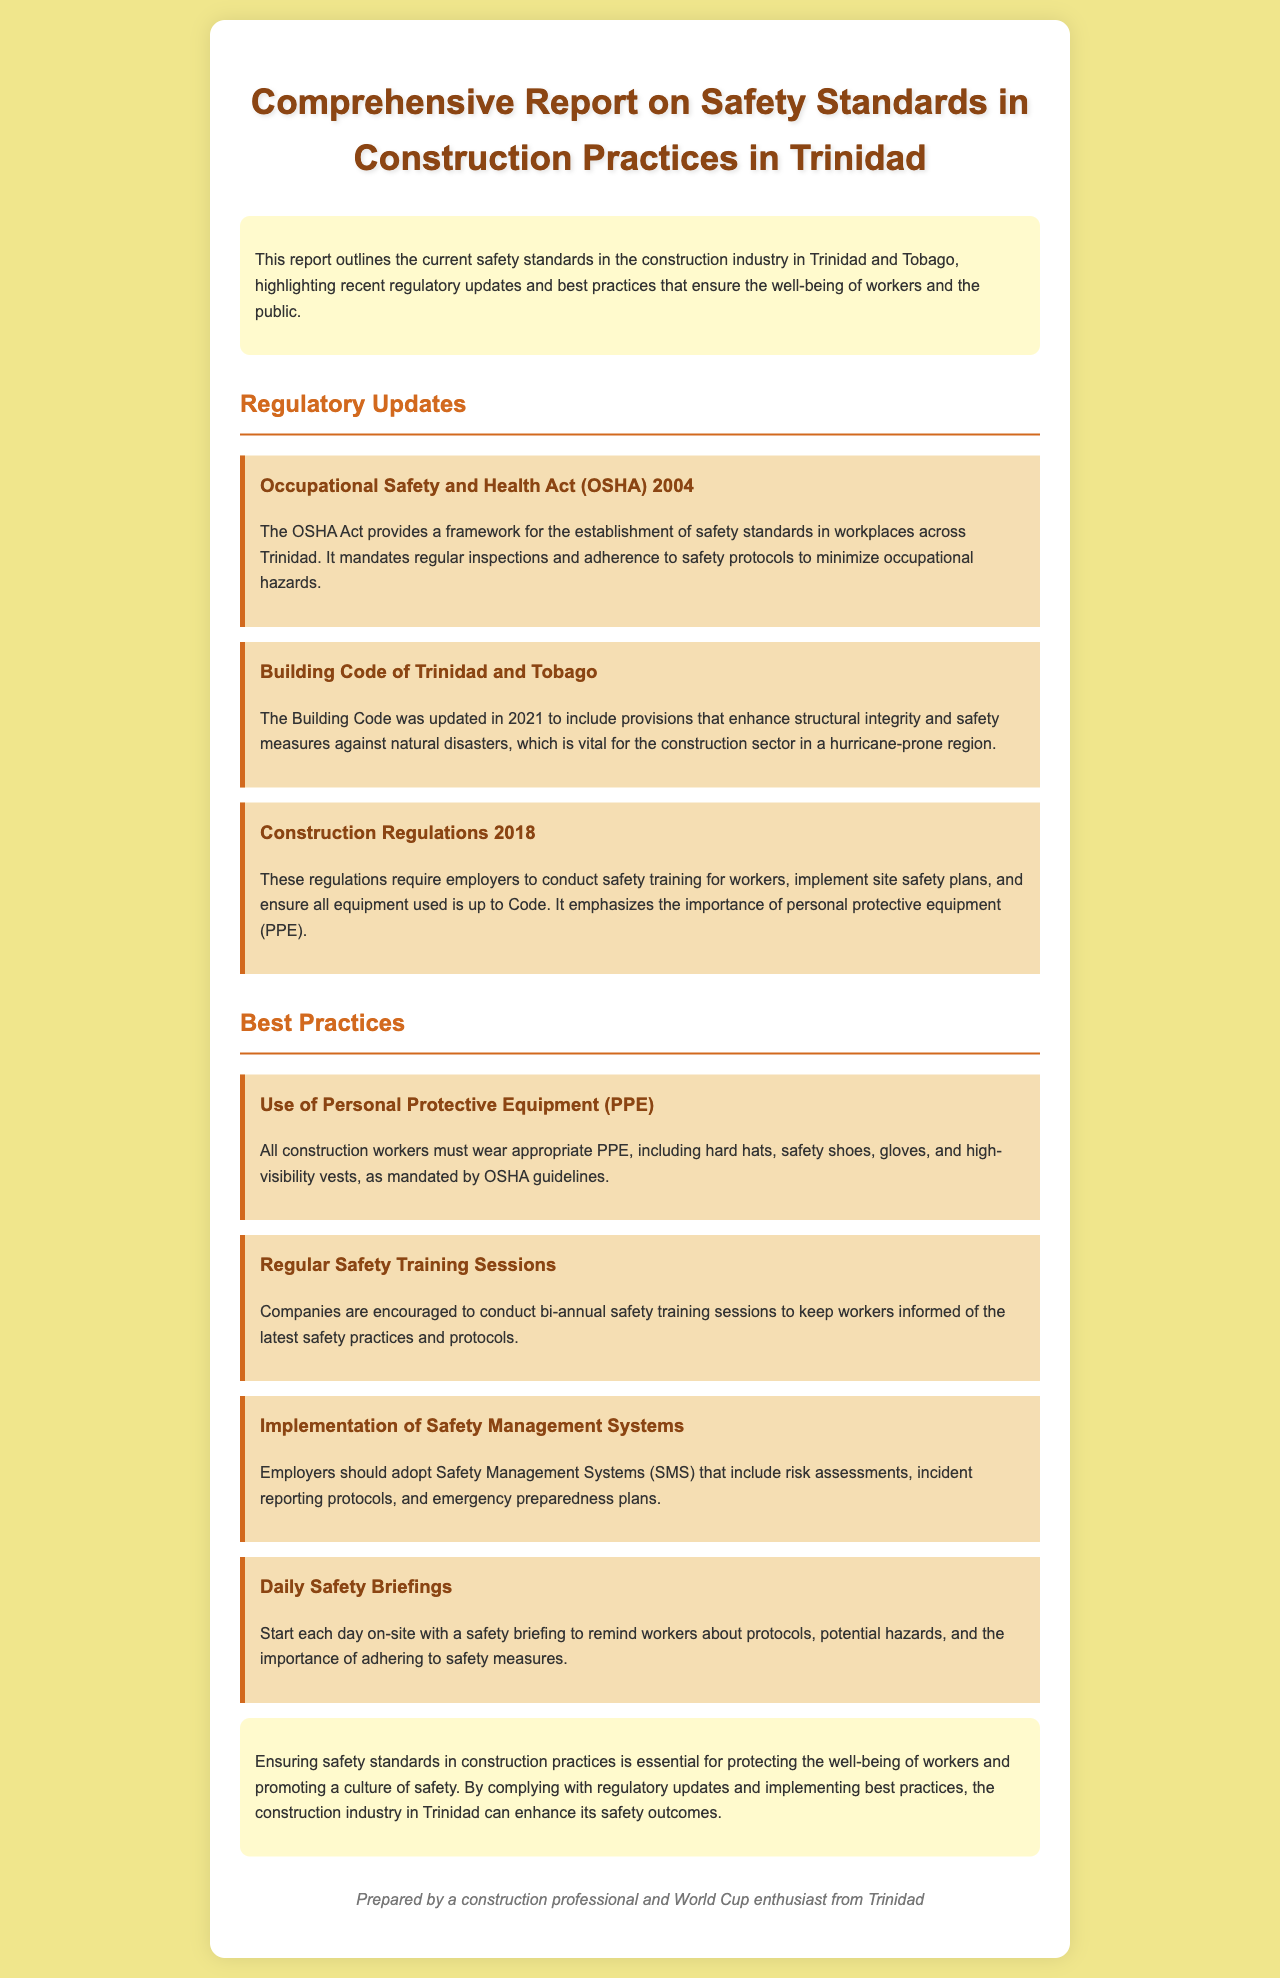What is the main framework for safety standards in Trinidad? The main framework for safety standards in Trinidad is provided by the Occupational Safety and Health Act (OSHA) 2004.
Answer: Occupational Safety and Health Act (OSHA) 2004 When was the Building Code of Trinidad and Tobago updated? The Building Code of Trinidad and Tobago was updated in 2021.
Answer: 2021 What is required of employers under the Construction Regulations of 2018? Employers are required to conduct safety training for workers, implement site safety plans, and ensure equipment is up to Code.
Answer: Conduct safety training for workers What type of equipment must construction workers wear according to OSHA guidelines? Construction workers must wear appropriate personal protective equipment (PPE) such as hard hats and safety shoes.
Answer: Personal Protective Equipment (PPE) How often should companies conduct safety training sessions? Companies are encouraged to conduct safety training sessions bi-annually.
Answer: Bi-annually What is one best practice for promoting safety on construction sites? A best practice for promoting safety on construction sites is to start each day with a safety briefing.
Answer: Safety briefing What does SMS stand for in the context of safety management? SMS stands for Safety Management Systems.
Answer: Safety Management Systems What is the role of the conclusion in the report? The conclusion emphasizes the importance of compliance with safety standards and the implementation of best practices.
Answer: Emphasizes importance of safety compliance 